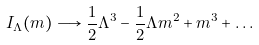<formula> <loc_0><loc_0><loc_500><loc_500>I _ { \Lambda } ( m ) \longrightarrow \frac { 1 } { 2 } \Lambda ^ { 3 } - \frac { 1 } { 2 } \Lambda m ^ { 2 } + m ^ { 3 } + \dots</formula> 